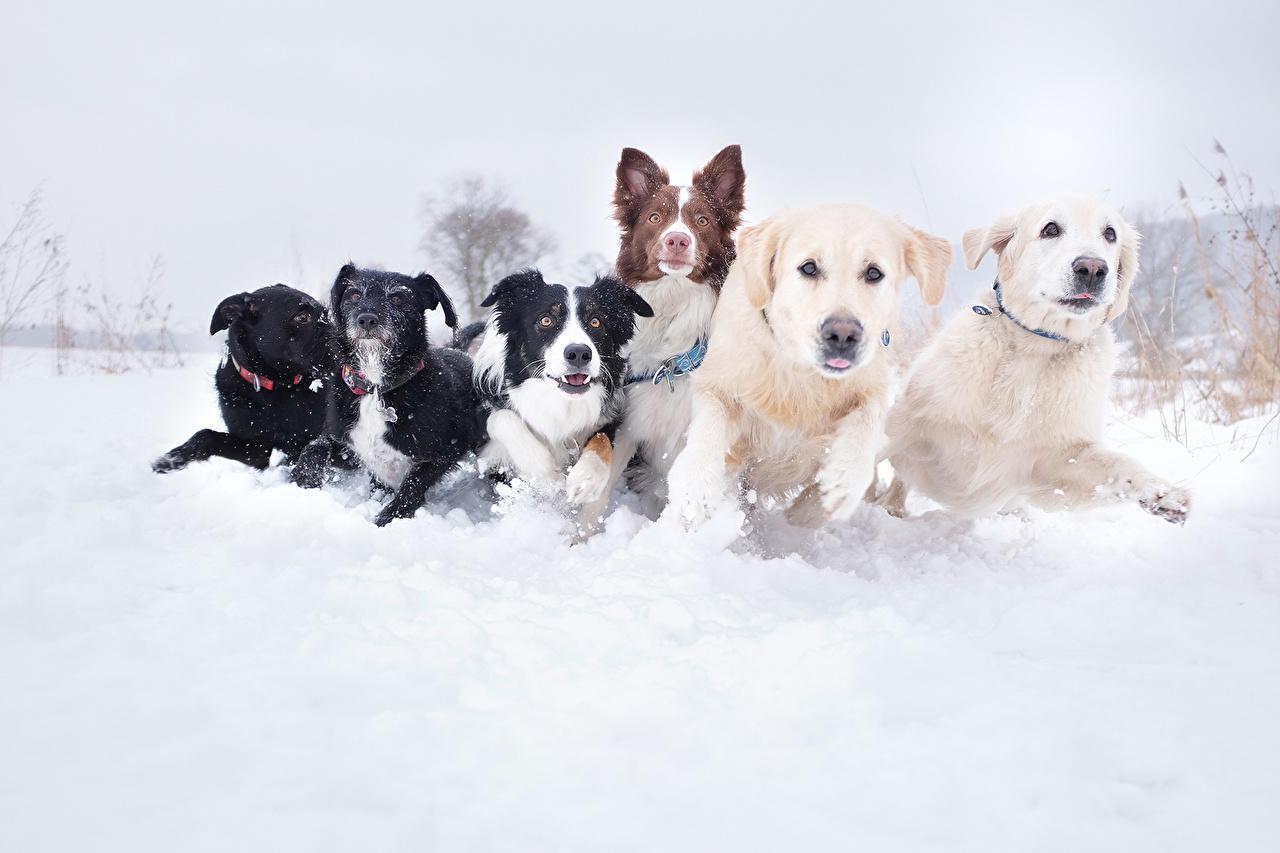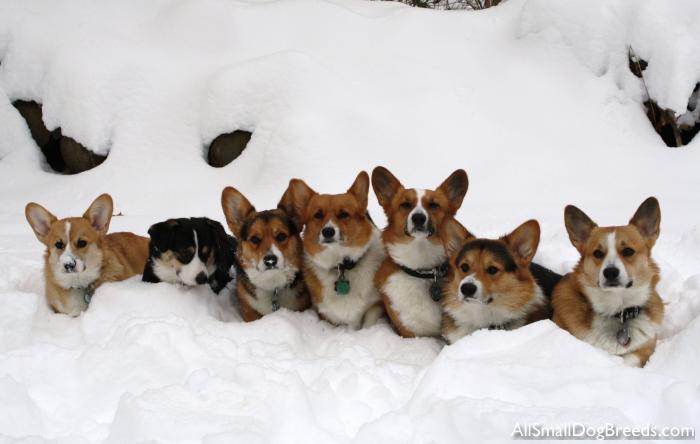The first image is the image on the left, the second image is the image on the right. Analyze the images presented: Is the assertion "There are exactly 3 dogs." valid? Answer yes or no. No. The first image is the image on the left, the second image is the image on the right. Evaluate the accuracy of this statement regarding the images: "There are three dogs in the image pair.". Is it true? Answer yes or no. No. 